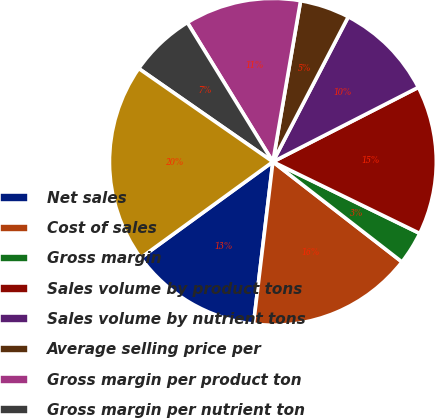<chart> <loc_0><loc_0><loc_500><loc_500><pie_chart><fcel>Net sales<fcel>Cost of sales<fcel>Gross margin<fcel>Sales volume by product tons<fcel>Sales volume by nutrient tons<fcel>Average selling price per<fcel>Gross margin per product ton<fcel>Gross margin per nutrient ton<fcel>Depreciation and amortization<nl><fcel>13.11%<fcel>16.39%<fcel>3.28%<fcel>14.75%<fcel>9.84%<fcel>4.92%<fcel>11.48%<fcel>6.56%<fcel>19.67%<nl></chart> 